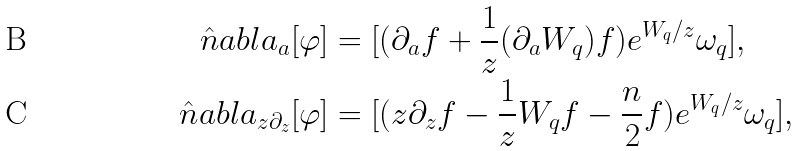<formula> <loc_0><loc_0><loc_500><loc_500>\hat { n } a b l a _ { a } [ \varphi ] & = [ ( \partial _ { a } f + \frac { 1 } { z } ( \partial _ { a } W _ { q } ) f ) e ^ { W _ { q } / z } \omega _ { q } ] , \\ \hat { n } a b l a _ { z \partial _ { z } } [ \varphi ] & = [ ( z \partial _ { z } f - \frac { 1 } { z } W _ { q } f - \frac { n } { 2 } f ) e ^ { W _ { q } / z } \omega _ { q } ] ,</formula> 